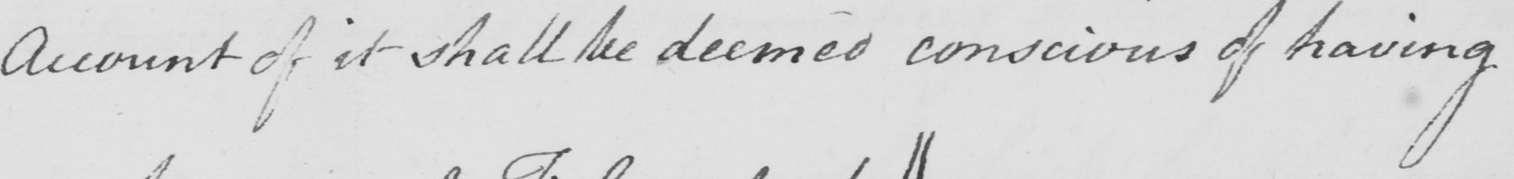What is written in this line of handwriting? Account of it shall be deemed conscious of having 